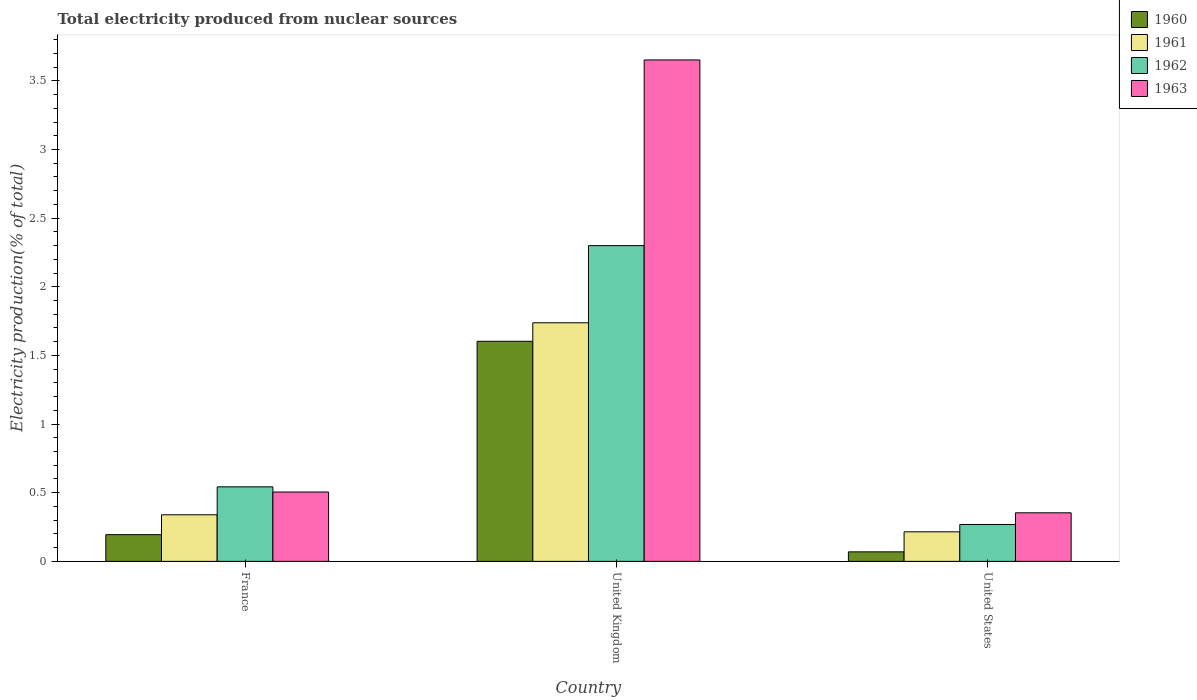Are the number of bars per tick equal to the number of legend labels?
Your answer should be compact. Yes. Are the number of bars on each tick of the X-axis equal?
Your answer should be very brief. Yes. How many bars are there on the 2nd tick from the left?
Offer a terse response. 4. How many bars are there on the 3rd tick from the right?
Make the answer very short. 4. In how many cases, is the number of bars for a given country not equal to the number of legend labels?
Offer a terse response. 0. What is the total electricity produced in 1962 in United States?
Keep it short and to the point. 0.27. Across all countries, what is the maximum total electricity produced in 1963?
Offer a very short reply. 3.65. Across all countries, what is the minimum total electricity produced in 1963?
Give a very brief answer. 0.35. What is the total total electricity produced in 1960 in the graph?
Provide a short and direct response. 1.87. What is the difference between the total electricity produced in 1963 in United Kingdom and that in United States?
Give a very brief answer. 3.3. What is the difference between the total electricity produced in 1963 in United Kingdom and the total electricity produced in 1960 in United States?
Offer a very short reply. 3.58. What is the average total electricity produced in 1963 per country?
Keep it short and to the point. 1.5. What is the difference between the total electricity produced of/in 1963 and total electricity produced of/in 1962 in United Kingdom?
Provide a succinct answer. 1.35. In how many countries, is the total electricity produced in 1962 greater than 2.7 %?
Ensure brevity in your answer.  0. What is the ratio of the total electricity produced in 1960 in France to that in United States?
Provide a succinct answer. 2.81. Is the total electricity produced in 1961 in United Kingdom less than that in United States?
Provide a short and direct response. No. What is the difference between the highest and the second highest total electricity produced in 1960?
Provide a succinct answer. -1.41. What is the difference between the highest and the lowest total electricity produced in 1962?
Your response must be concise. 2.03. Is the sum of the total electricity produced in 1960 in France and United States greater than the maximum total electricity produced in 1961 across all countries?
Ensure brevity in your answer.  No. Is it the case that in every country, the sum of the total electricity produced in 1963 and total electricity produced in 1962 is greater than the sum of total electricity produced in 1960 and total electricity produced in 1961?
Offer a very short reply. No. What does the 4th bar from the left in United States represents?
Provide a short and direct response. 1963. What does the 4th bar from the right in United Kingdom represents?
Provide a short and direct response. 1960. Does the graph contain grids?
Your answer should be very brief. No. How many legend labels are there?
Keep it short and to the point. 4. What is the title of the graph?
Keep it short and to the point. Total electricity produced from nuclear sources. Does "1981" appear as one of the legend labels in the graph?
Your response must be concise. No. What is the label or title of the Y-axis?
Offer a very short reply. Electricity production(% of total). What is the Electricity production(% of total) of 1960 in France?
Provide a succinct answer. 0.19. What is the Electricity production(% of total) of 1961 in France?
Keep it short and to the point. 0.34. What is the Electricity production(% of total) of 1962 in France?
Your answer should be compact. 0.54. What is the Electricity production(% of total) of 1963 in France?
Make the answer very short. 0.51. What is the Electricity production(% of total) in 1960 in United Kingdom?
Your answer should be very brief. 1.6. What is the Electricity production(% of total) in 1961 in United Kingdom?
Provide a succinct answer. 1.74. What is the Electricity production(% of total) of 1962 in United Kingdom?
Offer a terse response. 2.3. What is the Electricity production(% of total) of 1963 in United Kingdom?
Your response must be concise. 3.65. What is the Electricity production(% of total) in 1960 in United States?
Offer a terse response. 0.07. What is the Electricity production(% of total) of 1961 in United States?
Provide a succinct answer. 0.22. What is the Electricity production(% of total) of 1962 in United States?
Keep it short and to the point. 0.27. What is the Electricity production(% of total) in 1963 in United States?
Offer a very short reply. 0.35. Across all countries, what is the maximum Electricity production(% of total) in 1960?
Provide a short and direct response. 1.6. Across all countries, what is the maximum Electricity production(% of total) in 1961?
Your answer should be very brief. 1.74. Across all countries, what is the maximum Electricity production(% of total) in 1962?
Your answer should be very brief. 2.3. Across all countries, what is the maximum Electricity production(% of total) in 1963?
Make the answer very short. 3.65. Across all countries, what is the minimum Electricity production(% of total) of 1960?
Ensure brevity in your answer.  0.07. Across all countries, what is the minimum Electricity production(% of total) of 1961?
Provide a succinct answer. 0.22. Across all countries, what is the minimum Electricity production(% of total) of 1962?
Provide a short and direct response. 0.27. Across all countries, what is the minimum Electricity production(% of total) of 1963?
Your answer should be very brief. 0.35. What is the total Electricity production(% of total) in 1960 in the graph?
Ensure brevity in your answer.  1.87. What is the total Electricity production(% of total) in 1961 in the graph?
Make the answer very short. 2.29. What is the total Electricity production(% of total) in 1962 in the graph?
Give a very brief answer. 3.11. What is the total Electricity production(% of total) of 1963 in the graph?
Make the answer very short. 4.51. What is the difference between the Electricity production(% of total) of 1960 in France and that in United Kingdom?
Offer a very short reply. -1.41. What is the difference between the Electricity production(% of total) in 1961 in France and that in United Kingdom?
Your answer should be very brief. -1.4. What is the difference between the Electricity production(% of total) in 1962 in France and that in United Kingdom?
Provide a succinct answer. -1.76. What is the difference between the Electricity production(% of total) in 1963 in France and that in United Kingdom?
Your answer should be compact. -3.15. What is the difference between the Electricity production(% of total) of 1960 in France and that in United States?
Offer a terse response. 0.13. What is the difference between the Electricity production(% of total) of 1961 in France and that in United States?
Offer a terse response. 0.12. What is the difference between the Electricity production(% of total) in 1962 in France and that in United States?
Keep it short and to the point. 0.27. What is the difference between the Electricity production(% of total) of 1963 in France and that in United States?
Offer a terse response. 0.15. What is the difference between the Electricity production(% of total) in 1960 in United Kingdom and that in United States?
Your answer should be very brief. 1.53. What is the difference between the Electricity production(% of total) in 1961 in United Kingdom and that in United States?
Keep it short and to the point. 1.52. What is the difference between the Electricity production(% of total) in 1962 in United Kingdom and that in United States?
Keep it short and to the point. 2.03. What is the difference between the Electricity production(% of total) of 1963 in United Kingdom and that in United States?
Your answer should be compact. 3.3. What is the difference between the Electricity production(% of total) of 1960 in France and the Electricity production(% of total) of 1961 in United Kingdom?
Keep it short and to the point. -1.54. What is the difference between the Electricity production(% of total) of 1960 in France and the Electricity production(% of total) of 1962 in United Kingdom?
Ensure brevity in your answer.  -2.11. What is the difference between the Electricity production(% of total) of 1960 in France and the Electricity production(% of total) of 1963 in United Kingdom?
Make the answer very short. -3.46. What is the difference between the Electricity production(% of total) in 1961 in France and the Electricity production(% of total) in 1962 in United Kingdom?
Provide a short and direct response. -1.96. What is the difference between the Electricity production(% of total) of 1961 in France and the Electricity production(% of total) of 1963 in United Kingdom?
Keep it short and to the point. -3.31. What is the difference between the Electricity production(% of total) in 1962 in France and the Electricity production(% of total) in 1963 in United Kingdom?
Your response must be concise. -3.11. What is the difference between the Electricity production(% of total) in 1960 in France and the Electricity production(% of total) in 1961 in United States?
Provide a succinct answer. -0.02. What is the difference between the Electricity production(% of total) in 1960 in France and the Electricity production(% of total) in 1962 in United States?
Give a very brief answer. -0.07. What is the difference between the Electricity production(% of total) of 1960 in France and the Electricity production(% of total) of 1963 in United States?
Your answer should be very brief. -0.16. What is the difference between the Electricity production(% of total) in 1961 in France and the Electricity production(% of total) in 1962 in United States?
Keep it short and to the point. 0.07. What is the difference between the Electricity production(% of total) of 1961 in France and the Electricity production(% of total) of 1963 in United States?
Your answer should be compact. -0.01. What is the difference between the Electricity production(% of total) of 1962 in France and the Electricity production(% of total) of 1963 in United States?
Provide a succinct answer. 0.19. What is the difference between the Electricity production(% of total) in 1960 in United Kingdom and the Electricity production(% of total) in 1961 in United States?
Ensure brevity in your answer.  1.39. What is the difference between the Electricity production(% of total) in 1960 in United Kingdom and the Electricity production(% of total) in 1962 in United States?
Provide a short and direct response. 1.33. What is the difference between the Electricity production(% of total) in 1960 in United Kingdom and the Electricity production(% of total) in 1963 in United States?
Your answer should be very brief. 1.25. What is the difference between the Electricity production(% of total) of 1961 in United Kingdom and the Electricity production(% of total) of 1962 in United States?
Give a very brief answer. 1.47. What is the difference between the Electricity production(% of total) in 1961 in United Kingdom and the Electricity production(% of total) in 1963 in United States?
Your response must be concise. 1.38. What is the difference between the Electricity production(% of total) of 1962 in United Kingdom and the Electricity production(% of total) of 1963 in United States?
Provide a succinct answer. 1.95. What is the average Electricity production(% of total) of 1960 per country?
Provide a succinct answer. 0.62. What is the average Electricity production(% of total) of 1961 per country?
Your response must be concise. 0.76. What is the average Electricity production(% of total) of 1963 per country?
Offer a very short reply. 1.5. What is the difference between the Electricity production(% of total) of 1960 and Electricity production(% of total) of 1961 in France?
Give a very brief answer. -0.14. What is the difference between the Electricity production(% of total) in 1960 and Electricity production(% of total) in 1962 in France?
Provide a succinct answer. -0.35. What is the difference between the Electricity production(% of total) of 1960 and Electricity production(% of total) of 1963 in France?
Ensure brevity in your answer.  -0.31. What is the difference between the Electricity production(% of total) of 1961 and Electricity production(% of total) of 1962 in France?
Offer a very short reply. -0.2. What is the difference between the Electricity production(% of total) of 1961 and Electricity production(% of total) of 1963 in France?
Provide a short and direct response. -0.17. What is the difference between the Electricity production(% of total) in 1962 and Electricity production(% of total) in 1963 in France?
Keep it short and to the point. 0.04. What is the difference between the Electricity production(% of total) of 1960 and Electricity production(% of total) of 1961 in United Kingdom?
Provide a succinct answer. -0.13. What is the difference between the Electricity production(% of total) in 1960 and Electricity production(% of total) in 1962 in United Kingdom?
Provide a succinct answer. -0.7. What is the difference between the Electricity production(% of total) in 1960 and Electricity production(% of total) in 1963 in United Kingdom?
Give a very brief answer. -2.05. What is the difference between the Electricity production(% of total) of 1961 and Electricity production(% of total) of 1962 in United Kingdom?
Offer a very short reply. -0.56. What is the difference between the Electricity production(% of total) in 1961 and Electricity production(% of total) in 1963 in United Kingdom?
Your answer should be compact. -1.91. What is the difference between the Electricity production(% of total) in 1962 and Electricity production(% of total) in 1963 in United Kingdom?
Your response must be concise. -1.35. What is the difference between the Electricity production(% of total) of 1960 and Electricity production(% of total) of 1961 in United States?
Keep it short and to the point. -0.15. What is the difference between the Electricity production(% of total) in 1960 and Electricity production(% of total) in 1962 in United States?
Keep it short and to the point. -0.2. What is the difference between the Electricity production(% of total) of 1960 and Electricity production(% of total) of 1963 in United States?
Make the answer very short. -0.28. What is the difference between the Electricity production(% of total) of 1961 and Electricity production(% of total) of 1962 in United States?
Keep it short and to the point. -0.05. What is the difference between the Electricity production(% of total) in 1961 and Electricity production(% of total) in 1963 in United States?
Give a very brief answer. -0.14. What is the difference between the Electricity production(% of total) in 1962 and Electricity production(% of total) in 1963 in United States?
Provide a succinct answer. -0.09. What is the ratio of the Electricity production(% of total) in 1960 in France to that in United Kingdom?
Offer a terse response. 0.12. What is the ratio of the Electricity production(% of total) in 1961 in France to that in United Kingdom?
Your answer should be very brief. 0.2. What is the ratio of the Electricity production(% of total) in 1962 in France to that in United Kingdom?
Offer a terse response. 0.24. What is the ratio of the Electricity production(% of total) in 1963 in France to that in United Kingdom?
Give a very brief answer. 0.14. What is the ratio of the Electricity production(% of total) of 1960 in France to that in United States?
Provide a succinct answer. 2.81. What is the ratio of the Electricity production(% of total) in 1961 in France to that in United States?
Offer a very short reply. 1.58. What is the ratio of the Electricity production(% of total) in 1962 in France to that in United States?
Give a very brief answer. 2.02. What is the ratio of the Electricity production(% of total) in 1963 in France to that in United States?
Offer a terse response. 1.43. What is the ratio of the Electricity production(% of total) of 1960 in United Kingdom to that in United States?
Make the answer very short. 23.14. What is the ratio of the Electricity production(% of total) in 1961 in United Kingdom to that in United States?
Keep it short and to the point. 8.08. What is the ratio of the Electricity production(% of total) of 1962 in United Kingdom to that in United States?
Keep it short and to the point. 8.56. What is the ratio of the Electricity production(% of total) in 1963 in United Kingdom to that in United States?
Your answer should be compact. 10.32. What is the difference between the highest and the second highest Electricity production(% of total) of 1960?
Make the answer very short. 1.41. What is the difference between the highest and the second highest Electricity production(% of total) in 1961?
Offer a very short reply. 1.4. What is the difference between the highest and the second highest Electricity production(% of total) in 1962?
Offer a very short reply. 1.76. What is the difference between the highest and the second highest Electricity production(% of total) in 1963?
Your answer should be compact. 3.15. What is the difference between the highest and the lowest Electricity production(% of total) in 1960?
Provide a succinct answer. 1.53. What is the difference between the highest and the lowest Electricity production(% of total) of 1961?
Your response must be concise. 1.52. What is the difference between the highest and the lowest Electricity production(% of total) of 1962?
Ensure brevity in your answer.  2.03. What is the difference between the highest and the lowest Electricity production(% of total) in 1963?
Provide a short and direct response. 3.3. 